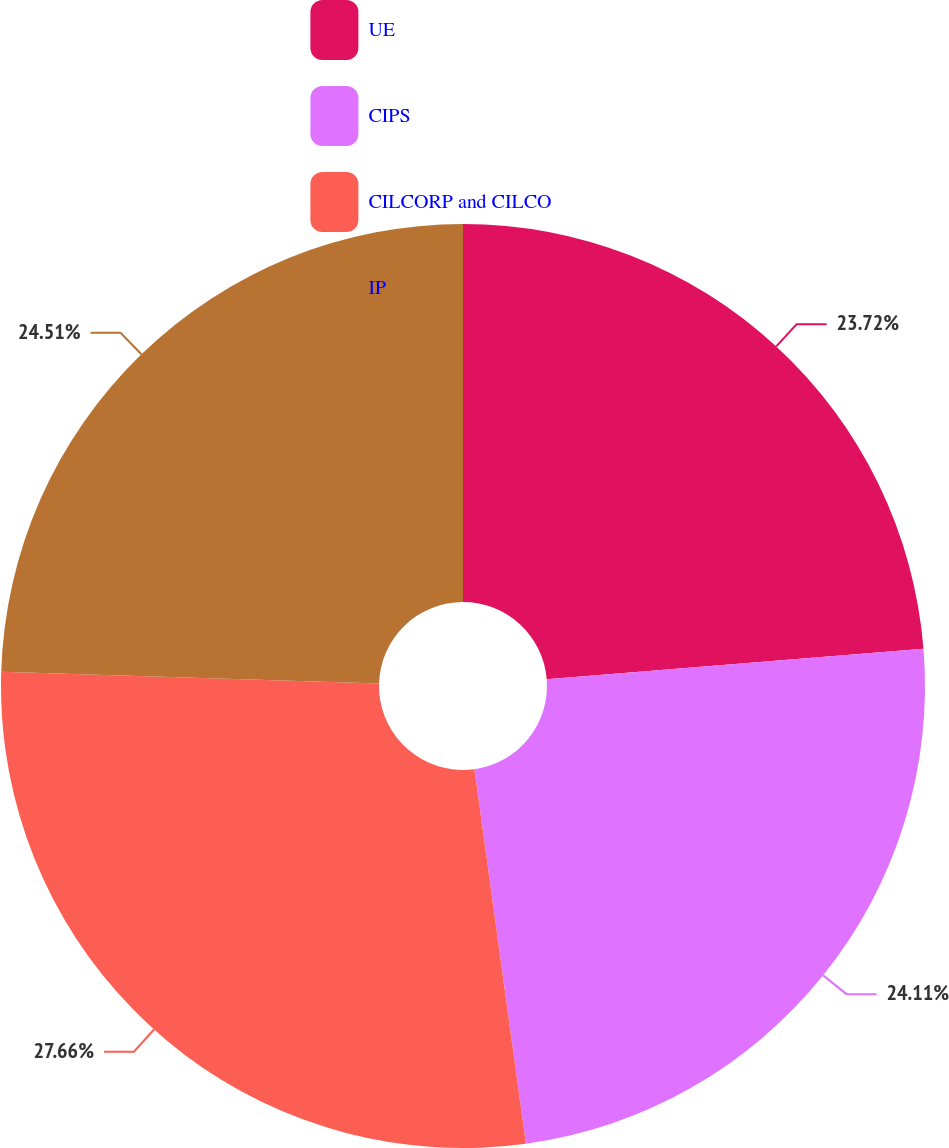Convert chart. <chart><loc_0><loc_0><loc_500><loc_500><pie_chart><fcel>UE<fcel>CIPS<fcel>CILCORP and CILCO<fcel>IP<nl><fcel>23.72%<fcel>24.11%<fcel>27.67%<fcel>24.51%<nl></chart> 